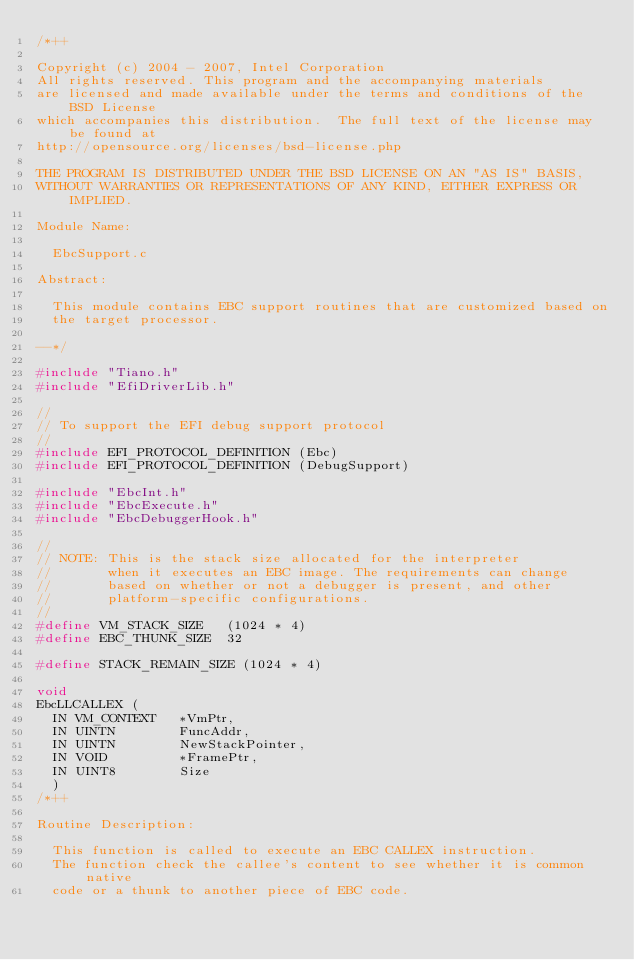<code> <loc_0><loc_0><loc_500><loc_500><_C_>/*++

Copyright (c) 2004 - 2007, Intel Corporation                                                         
All rights reserved. This program and the accompanying materials                          
are licensed and made available under the terms and conditions of the BSD License         
which accompanies this distribution.  The full text of the license may be found at        
http://opensource.org/licenses/bsd-license.php                                            
                                                                                          
THE PROGRAM IS DISTRIBUTED UNDER THE BSD LICENSE ON AN "AS IS" BASIS,                     
WITHOUT WARRANTIES OR REPRESENTATIONS OF ANY KIND, EITHER EXPRESS OR IMPLIED.             

Module Name:
 
  EbcSupport.c

Abstract:

  This module contains EBC support routines that are customized based on
  the target processor.

--*/

#include "Tiano.h"
#include "EfiDriverLib.h"

//
// To support the EFI debug support protocol
//
#include EFI_PROTOCOL_DEFINITION (Ebc)
#include EFI_PROTOCOL_DEFINITION (DebugSupport)

#include "EbcInt.h"
#include "EbcExecute.h"
#include "EbcDebuggerHook.h"

//
// NOTE: This is the stack size allocated for the interpreter
//       when it executes an EBC image. The requirements can change
//       based on whether or not a debugger is present, and other
//       platform-specific configurations.
//
#define VM_STACK_SIZE   (1024 * 4)
#define EBC_THUNK_SIZE  32

#define STACK_REMAIN_SIZE (1024 * 4)

void
EbcLLCALLEX (
  IN VM_CONTEXT   *VmPtr,
  IN UINTN        FuncAddr,
  IN UINTN        NewStackPointer,
  IN VOID         *FramePtr,
  IN UINT8        Size
  )
/*++

Routine Description:

  This function is called to execute an EBC CALLEX instruction. 
  The function check the callee's content to see whether it is common native
  code or a thunk to another piece of EBC code.</code> 